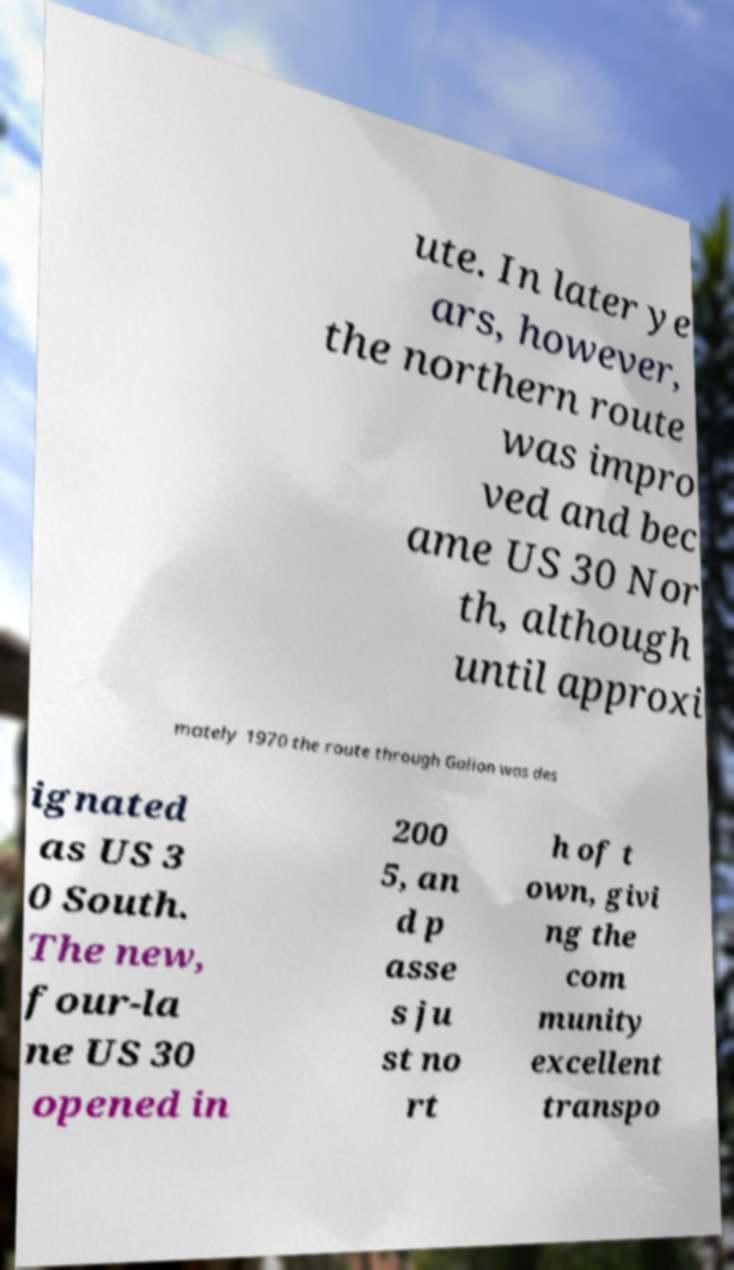I need the written content from this picture converted into text. Can you do that? ute. In later ye ars, however, the northern route was impro ved and bec ame US 30 Nor th, although until approxi mately 1970 the route through Galion was des ignated as US 3 0 South. The new, four-la ne US 30 opened in 200 5, an d p asse s ju st no rt h of t own, givi ng the com munity excellent transpo 